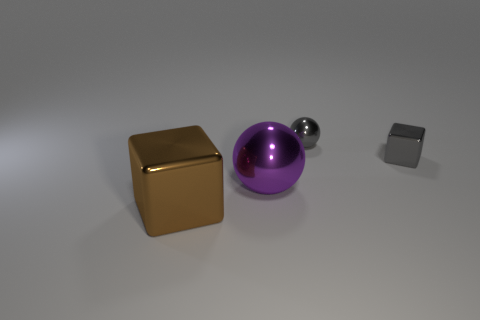Add 2 metal things. How many objects exist? 6 Subtract all gray things. Subtract all big brown metallic objects. How many objects are left? 1 Add 3 big brown metal cubes. How many big brown metal cubes are left? 4 Add 3 brown metallic things. How many brown metallic things exist? 4 Subtract 0 blue spheres. How many objects are left? 4 